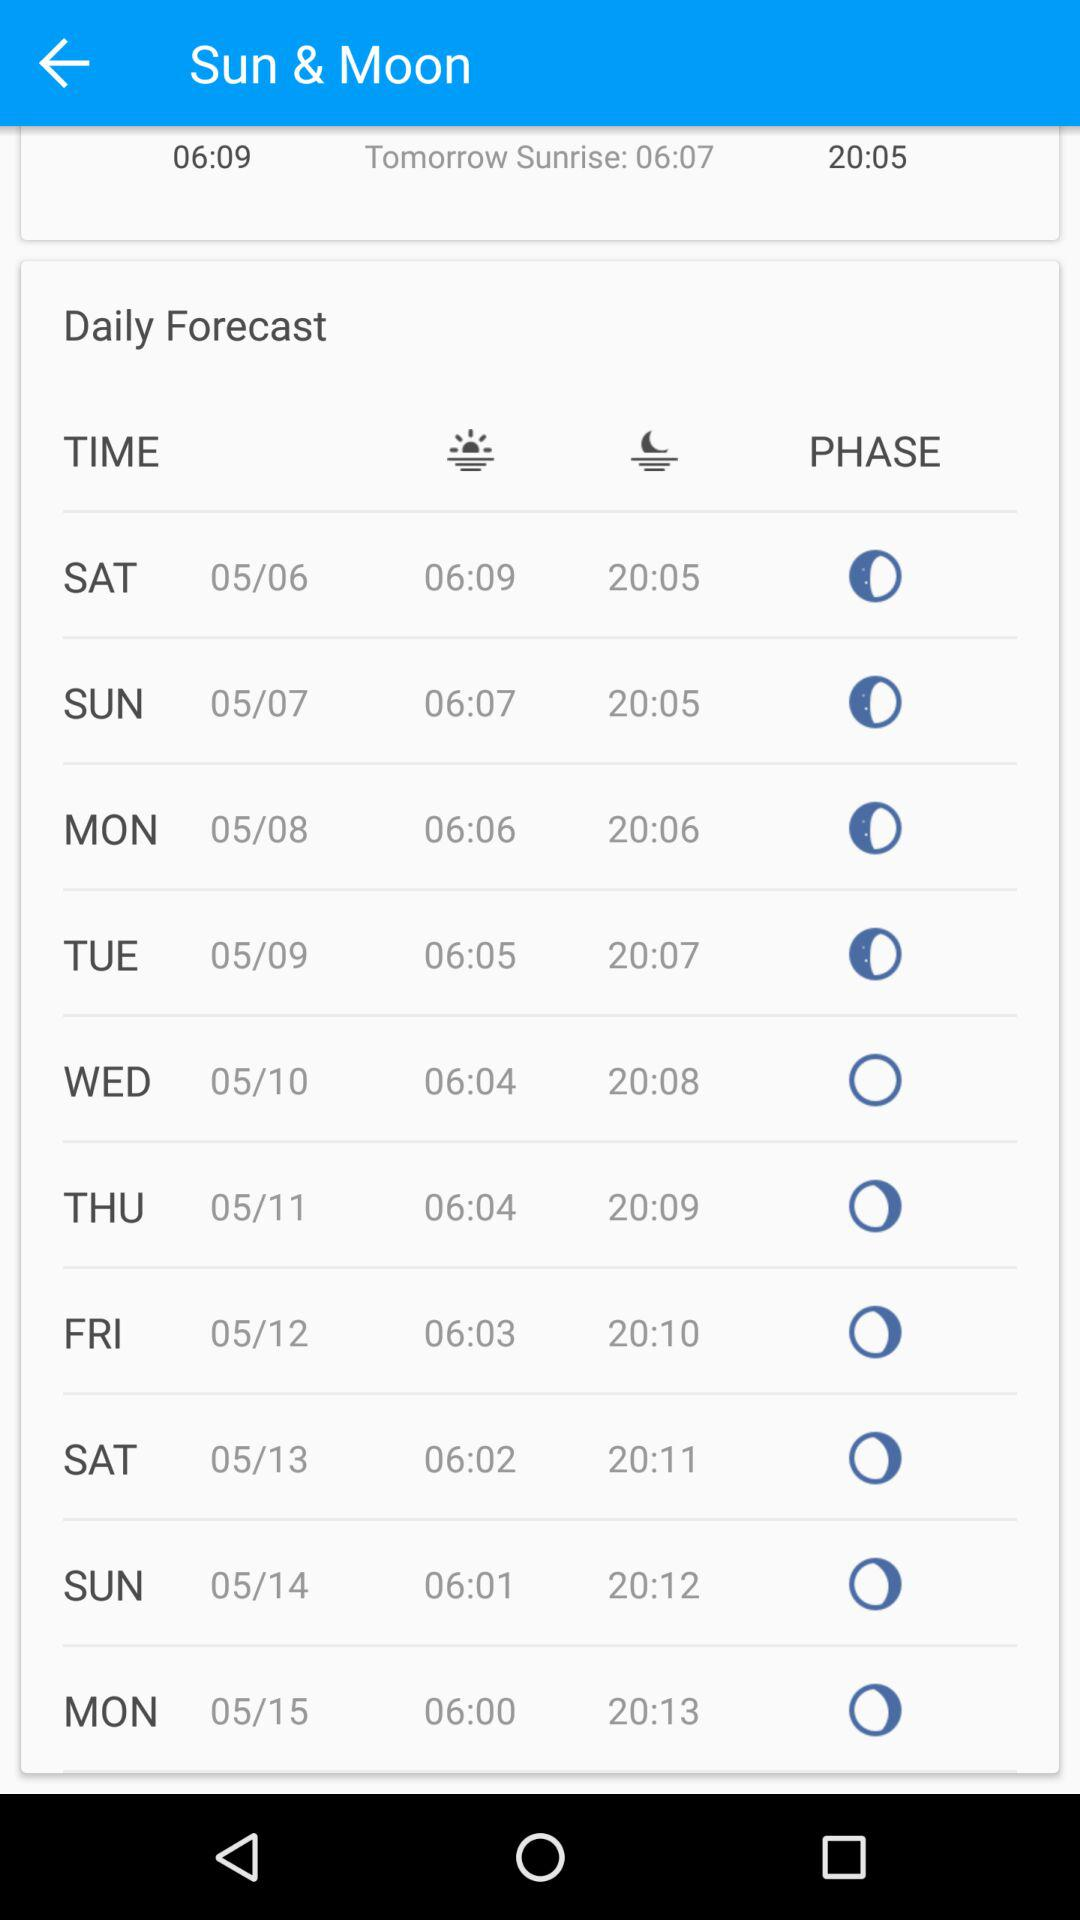What is the time of sunrise on Wednesday, May 10th? The time of sunrise is 06:04. 